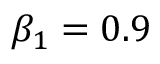<formula> <loc_0><loc_0><loc_500><loc_500>\beta _ { 1 } = 0 . 9</formula> 